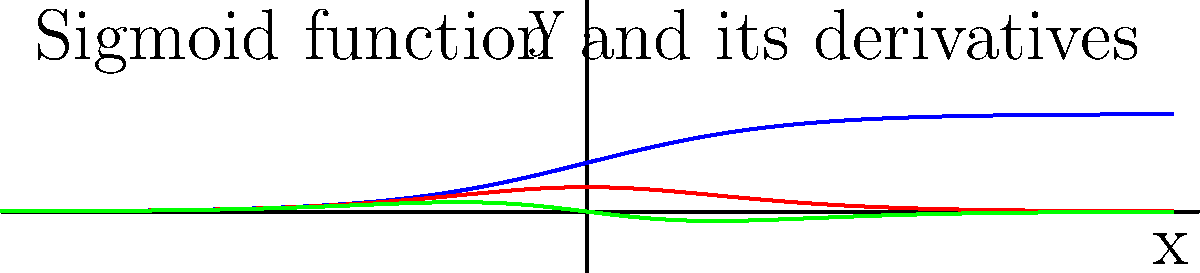Consider the sigmoid function $f(x) = \frac{1}{1 + e^{-x}}$. Using the graph provided, which shows the sigmoid function (blue), its first derivative (red), and its second derivative (green), determine the inflection point of the sigmoid function. Explain your reasoning based on the characteristics of the derivatives at this point. To find the inflection point of the sigmoid function, we need to follow these steps:

1) Recall that an inflection point occurs where the second derivative changes sign, or equivalently, where the second derivative equals zero.

2) From the graph, we can see that the green curve (second derivative) crosses the x-axis at x = 0.

3) At x = 0:
   - The sigmoid function (blue) is at its midpoint between 0 and 1.
   - The first derivative (red) reaches its maximum value.
   - The second derivative (green) equals zero and changes from positive to negative.

4) These observations confirm that x = 0 is indeed the inflection point:
   - The sigmoid function changes from concave up to concave down at this point.
   - The first derivative is at its maximum, indicating the steepest slope of the sigmoid function.
   - The second derivative changes sign, crossing zero.

5) We can verify this algebraically:
   $f'(x) = f(x)(1-f(x)) = \frac{e^x}{(1+e^x)^2}$
   $f''(x) = f'(x)(1-2f(x)) = \frac{e^x(1-e^x)}{(1+e^x)^3}$

   Setting $f''(x) = 0$, we get $1-e^x = 0$, which gives $x = 0$.

Therefore, the inflection point of the sigmoid function occurs at x = 0.
Answer: x = 0 